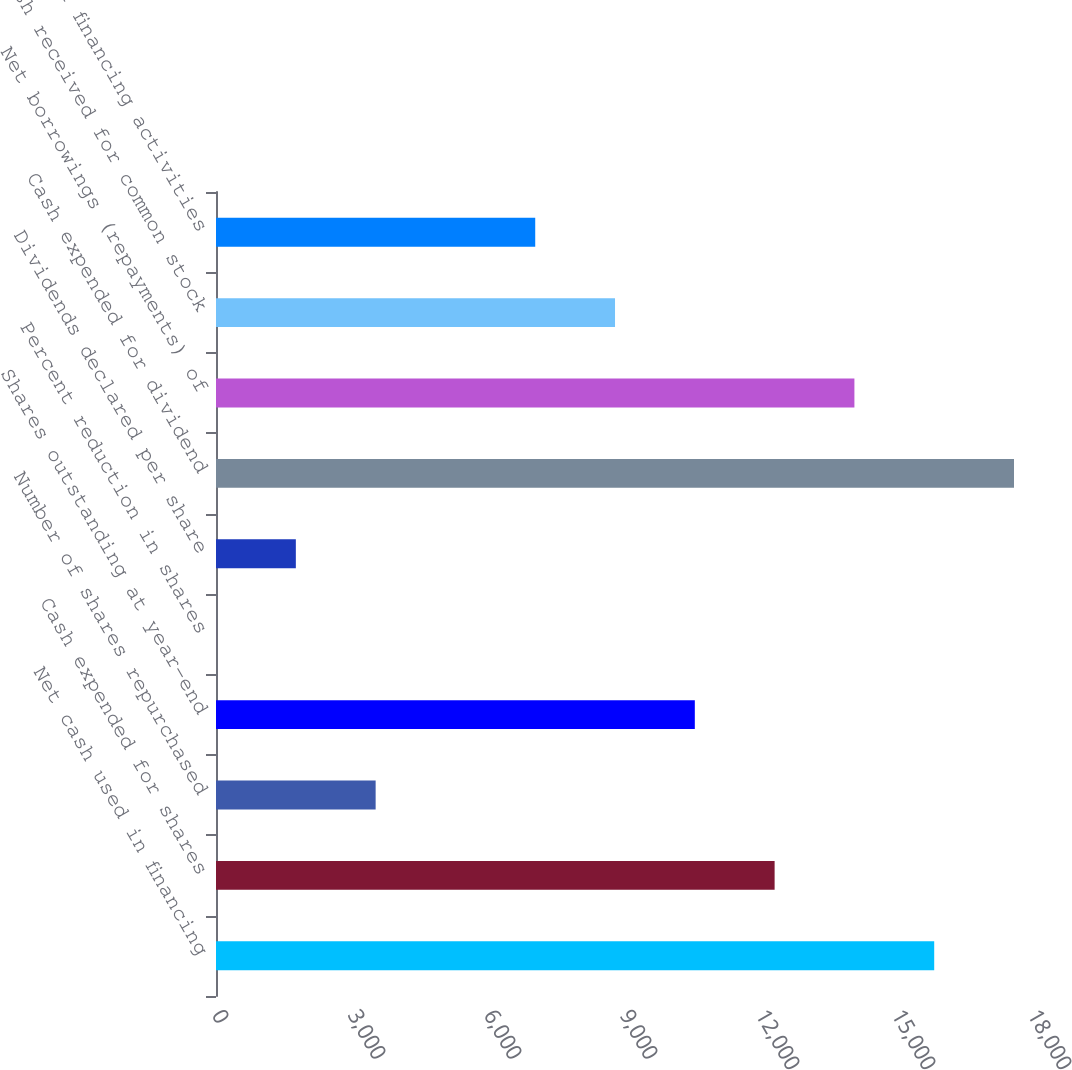<chart> <loc_0><loc_0><loc_500><loc_500><bar_chart><fcel>Net cash used in financing<fcel>Cash expended for shares<fcel>Number of shares repurchased<fcel>Shares outstanding at year-end<fcel>Percent reduction in shares<fcel>Dividends declared per share<fcel>Cash expended for dividend<fcel>Net borrowings (repayments) of<fcel>Cash received for common stock<fcel>Other financing activities<nl><fcel>15842.8<fcel>12322.4<fcel>3521.4<fcel>10562.2<fcel>1<fcel>1761.2<fcel>17603<fcel>14082.6<fcel>8802<fcel>7041.8<nl></chart> 